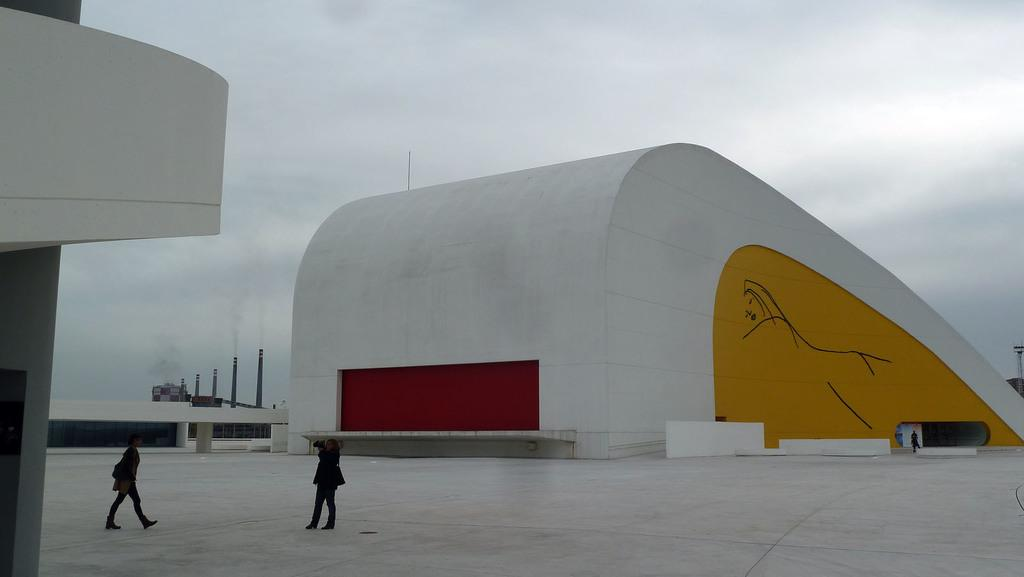What is the main action being performed by one of the humans in the image? One of the humans is walking in the image. What is the other human holding in the image? The other human is holding a camera in the image. What type of structure can be seen in the image? There is a building in the image. What are the pipes in the image used for? The pipes in the image are used for emitting smoke, as smoke is visible coming from them. What type of lettuce can be seen floating in the lake in the image? There is no lettuce or lake present in the image; it features a human walking, another human holding a camera, a building, pipes emitting smoke, and no reference to lettuce or a lake. 